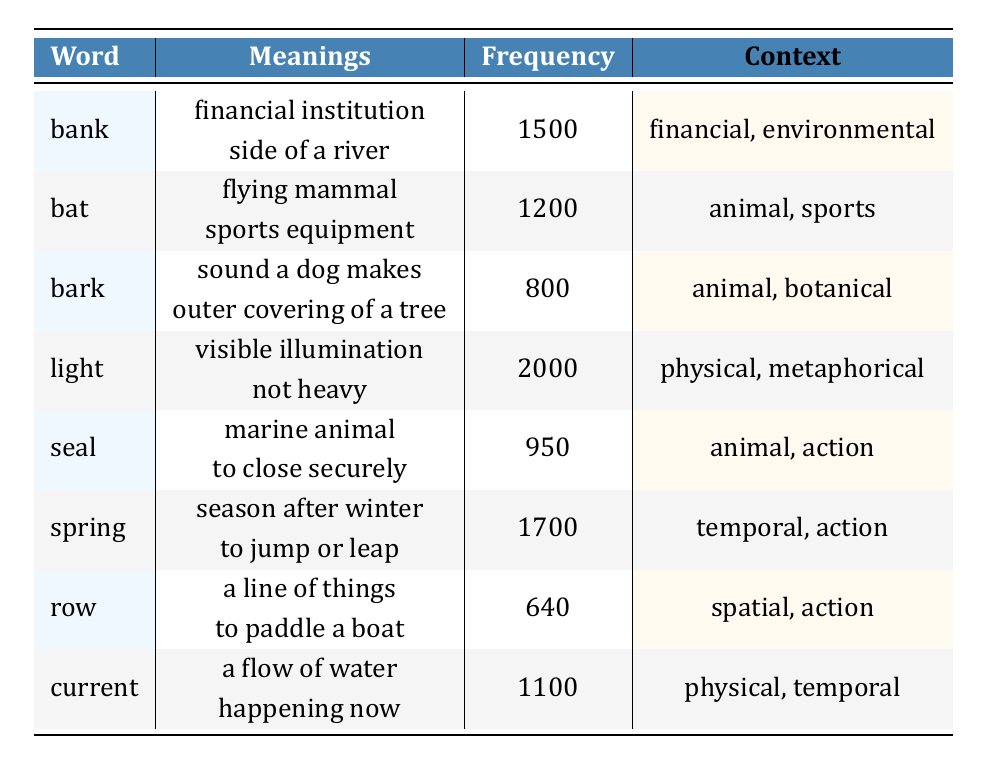What is the frequency of the word "light"? The table shows the frequency of "light" listed in the Frequency column, which is 2000.
Answer: 2000 Which word has the lowest frequency? Looking at the Frequency column, the lowest value is 640, associated with the word "row."
Answer: row How many total meanings are represented in the table? Each word has two meanings, and there are 8 words in the table, so the total number of meanings is 8 x 2 = 16.
Answer: 16 Is "bark" associated with both animal and botanical contexts? The context for "bark" includes "animal" and "botanical," as shown in the Context column. Therefore, the statement is true.
Answer: Yes What is the average frequency of the words in the table? To calculate the average: (1500 + 1200 + 800 + 2000 + 950 + 1700 + 640 + 1100) = 8090. Then divide by 8 (the number of words), which equals about 1011.25.
Answer: 1011.25 Which word has a financial context? The word "bank" is listed in the Context column with "financial" as one of its contexts.
Answer: bank How many words have "animal" as part of their context? The words "bat," "bark," and "seal" have "animal" listed in their respective Contexts. This results in a total of 3 words.
Answer: 3 What is the total frequency of words related to action? The words related to action are "seal," "spring," and "row." Their frequencies are 950, 1700, and 640, respectively. Summing them gives 950 + 1700 + 640 = 3290.
Answer: 3290 Is the word "current" associated with just temporal context? The Context column shows "current" has both "physical" and "temporal," so it is not exclusively temporal. Therefore, the statement is false.
Answer: No 